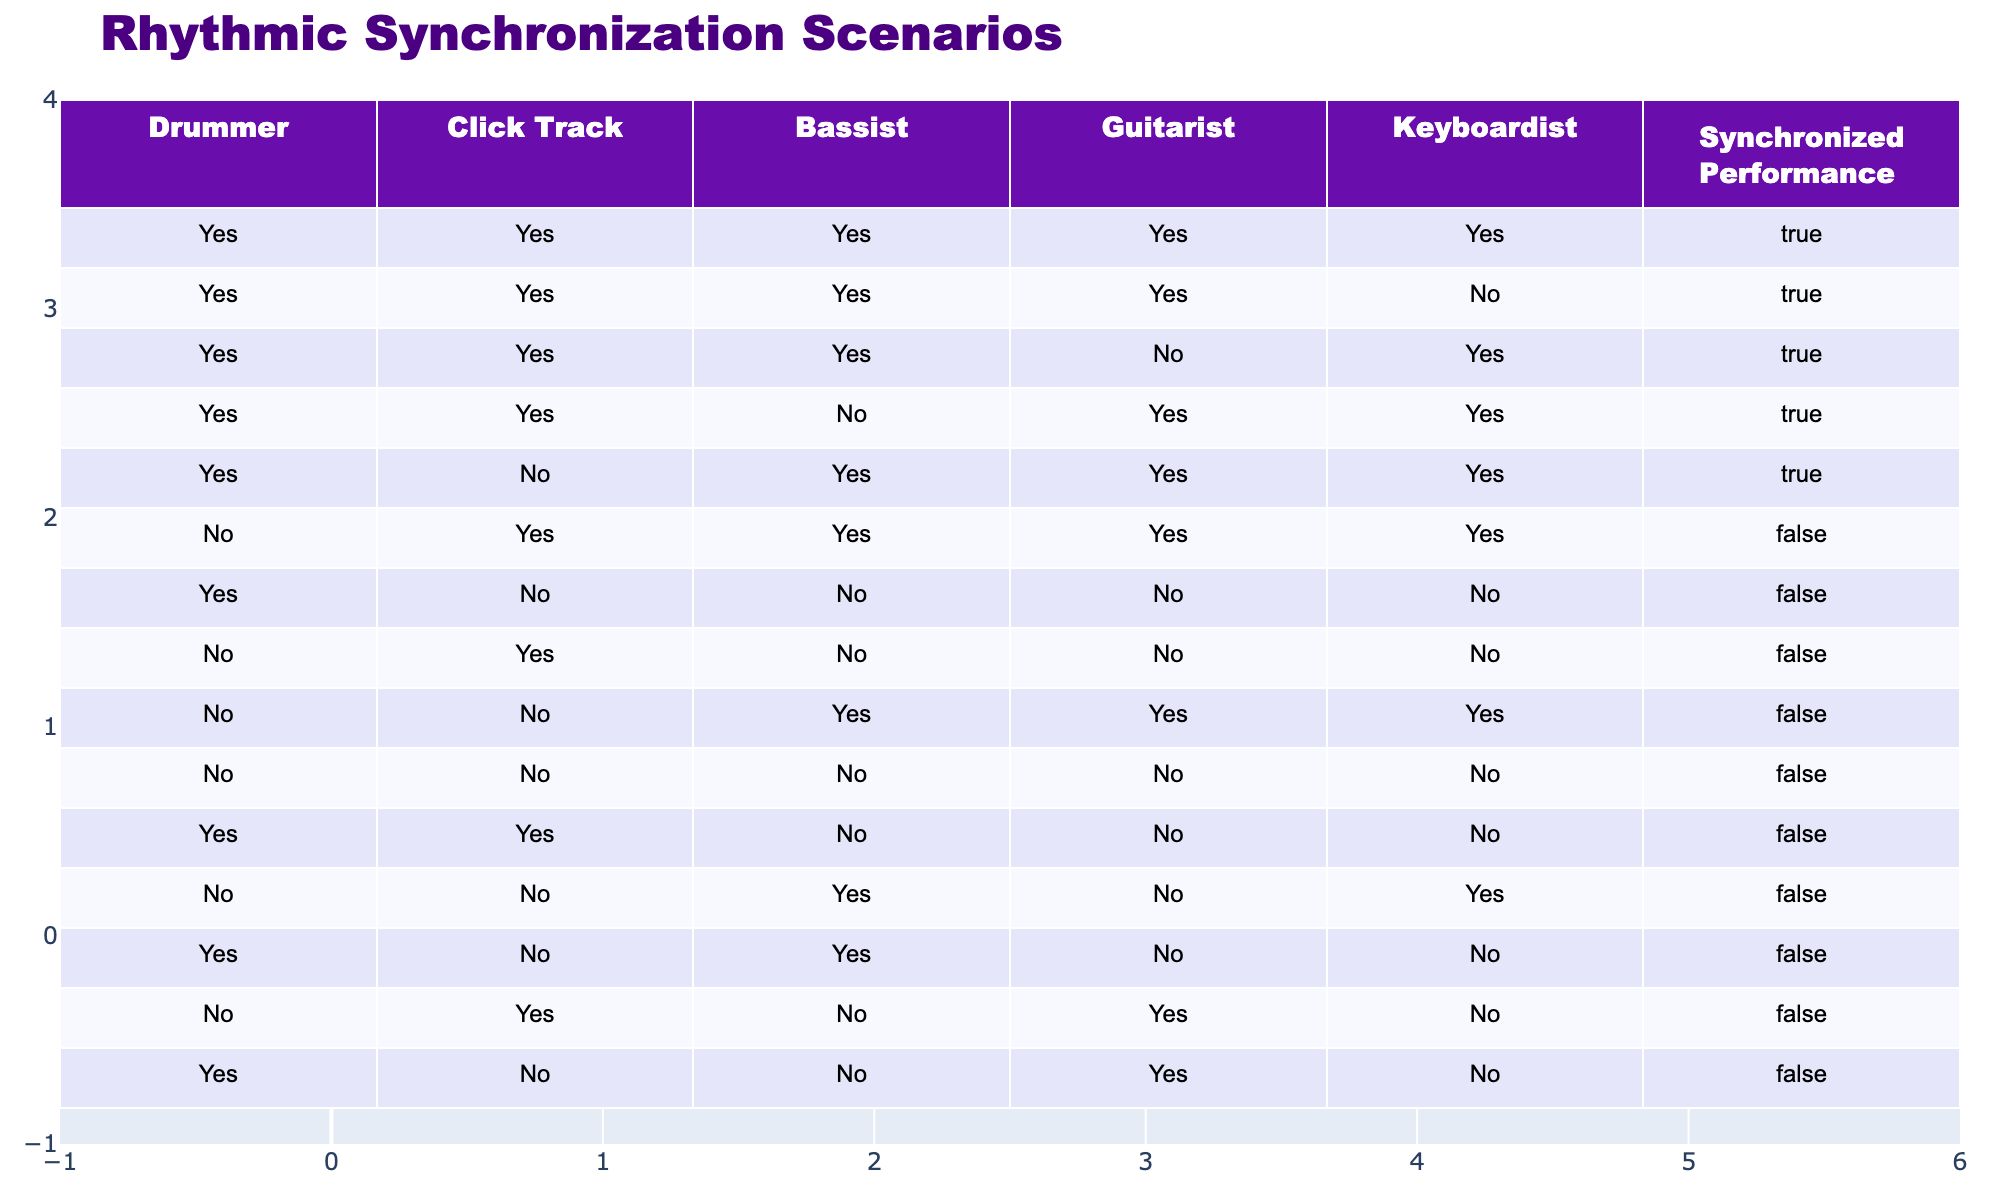What percentage of performances resulted in synchronized performances when the drummer used a click track? From the table, we can see that there are 6 performances where the drummer used a click track, and out of those, 5 resulted in synchronized performances. Therefore, the percentage is (5/6) * 100 = approximately 83.33%.
Answer: 83.33% How many performances had all band members on board but did not synchronize? Looking at the table, there’s one performance where the drummer, bassist, guitarist, and keyboardist were all involved (Yes for all), but they did not synchronize. This scenario is present in only one row.
Answer: 1 Is it true that if the drummer does not use a click track, the performance is rarely synchronized? Examining the cases where the drummer did not use a click track (4 cases), we find that only one of them resulted in synchronized performance. This indicates that the statement is indeed true.
Answer: Yes What is the ratio of synchronized performances to total performances in the table? There are 15 performances in total, of which 6 resulted in synchronization. Thus, the ratio is 6:15 or simplified down to 2:5.
Answer: 2:5 Which instrumentalist has the highest impact on synchronization based on the table data? Analyzing the table, we see that each time the drummer uses a click track, synchronization occurs regardless of other members. It seems that the drummer's presence and use of a click track greatly influence synchronization.
Answer: Drummer How many performances did not involve any musicians and resulted in poor synchronization? Referring to the table, there is one instance where the drummer, bassist, guitarist, and keyboardist were all absent (all No) and resulted in no synchronization.
Answer: 1 What combination of band member participation guarantees synchronization based on this table? The only combination that guarantees synchronization is when the drummer is playing (Yes) along with the click track and any combination of the other musicians. Every row meeting these conditions resulted in true.
Answer: Drummer with click track In how many cases did the bassist contribute to synchronization? The table shows that the bassist was involved in 6 performances, and out of these, synchronization happened in 5 cases, which implies the bassist contributes positively to synchronization when combined with others.
Answer: 5 